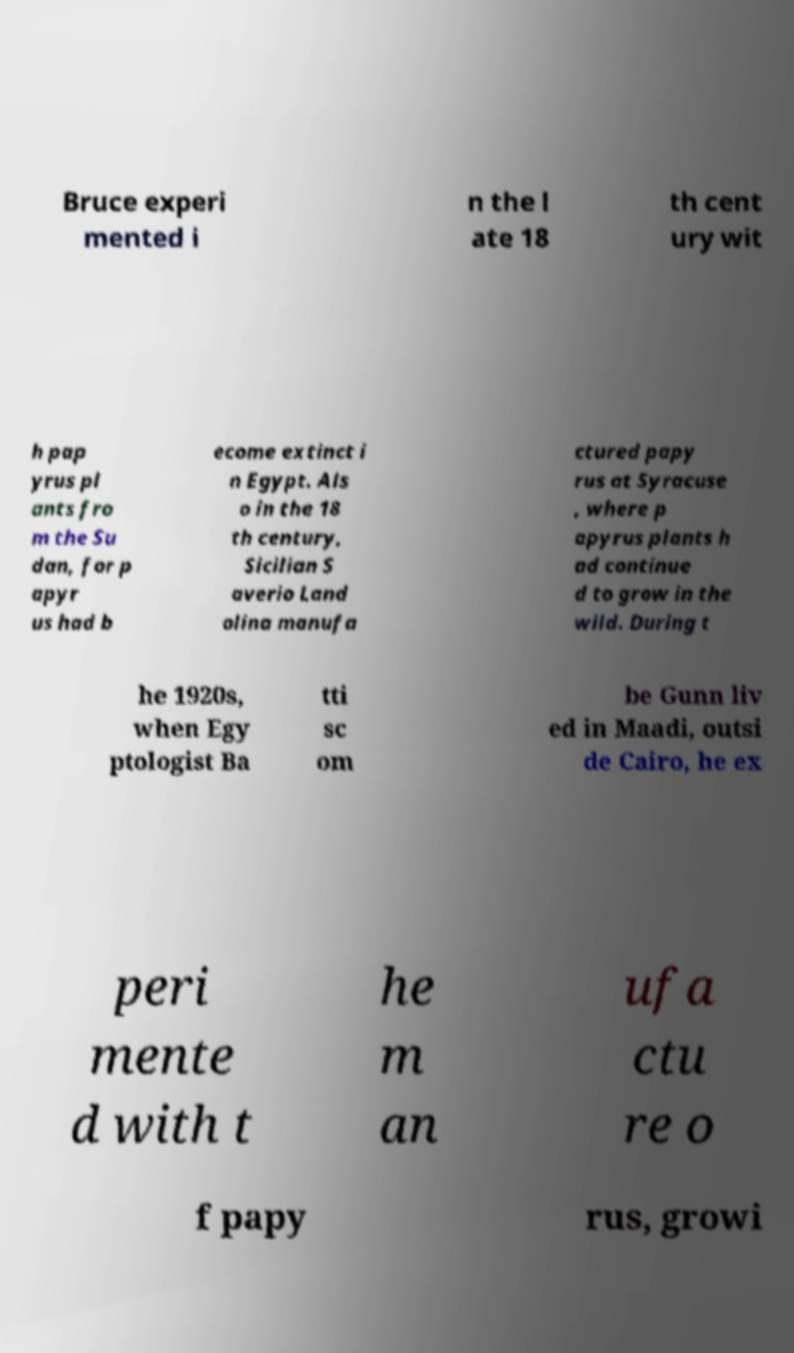Could you assist in decoding the text presented in this image and type it out clearly? Bruce experi mented i n the l ate 18 th cent ury wit h pap yrus pl ants fro m the Su dan, for p apyr us had b ecome extinct i n Egypt. Als o in the 18 th century, Sicilian S averio Land olina manufa ctured papy rus at Syracuse , where p apyrus plants h ad continue d to grow in the wild. During t he 1920s, when Egy ptologist Ba tti sc om be Gunn liv ed in Maadi, outsi de Cairo, he ex peri mente d with t he m an ufa ctu re o f papy rus, growi 